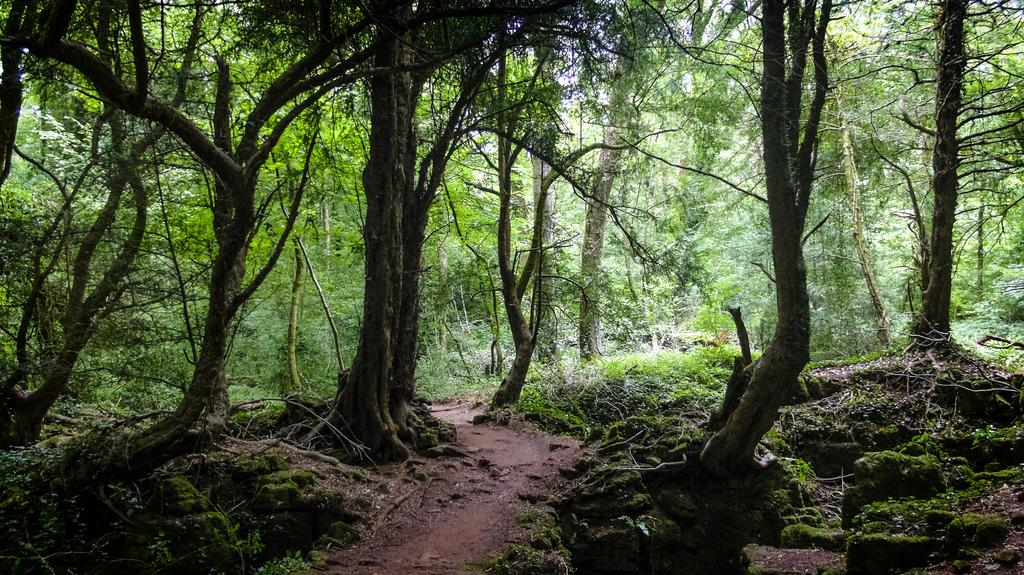What type of environment is shown in the image? The image depicts a forest area. What are the main features of the forest area? There are trees and plants in the image. How would you describe the overall appearance of the image? The image is full of greenery. What letters are being delivered to the forest in the image? There are no letters or parcels being delivered in the image; it simply shows a forest area with trees and plants. 